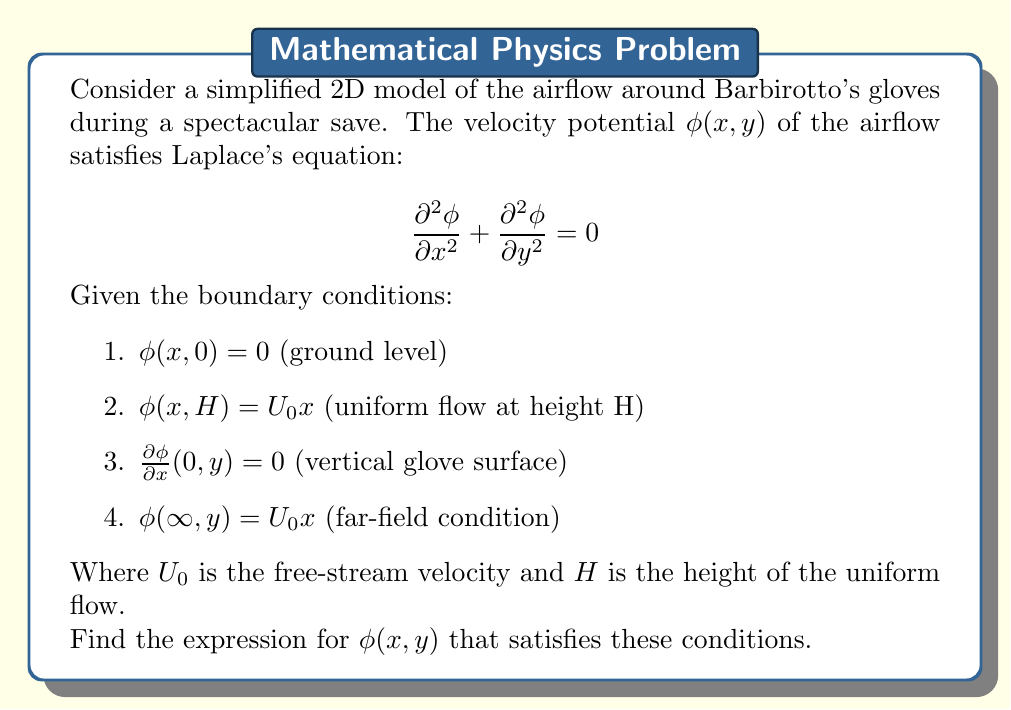Show me your answer to this math problem. To solve this partial differential equation (PDE) problem, we'll use the method of separation of variables.

1) Assume the solution has the form: $\phi(x,y) = X(x)Y(y)$

2) Substituting into Laplace's equation:

   $$Y\frac{d^2X}{dx^2} + X\frac{d^2Y}{dy^2} = 0$$

3) Dividing by $XY$:

   $$\frac{1}{X}\frac{d^2X}{dx^2} = -\frac{1}{Y}\frac{d^2Y}{dy^2} = k^2$$

   Where $k^2$ is a separation constant.

4) This gives us two ODEs:
   
   $$\frac{d^2X}{dx^2} - k^2X = 0$$
   $$\frac{d^2Y}{dy^2} + k^2Y = 0$$

5) The general solutions are:

   $$X(x) = Ae^{kx} + Be^{-kx}$$
   $$Y(y) = C\sin(ky) + D\cos(ky)$$

6) Applying the boundary conditions:

   From condition 1: $\phi(x,0) = 0 \implies D = 0$
   From condition 2: $\phi(x,H) = U_0x \implies C\sin(kH) = U_0x$
   From condition 3: $\frac{\partial\phi}{\partial x}(0,y) = 0 \implies A = B$
   From condition 4: $\phi(\infty,y) = U_0x \implies B = 0, k = 0$

7) The solution that satisfies all conditions is:

   $$\phi(x,y) = U_0x\frac{y}{H}$$

This represents a linear variation of the potential in both x and y directions.
Answer: $$\phi(x,y) = U_0x\frac{y}{H}$$ 